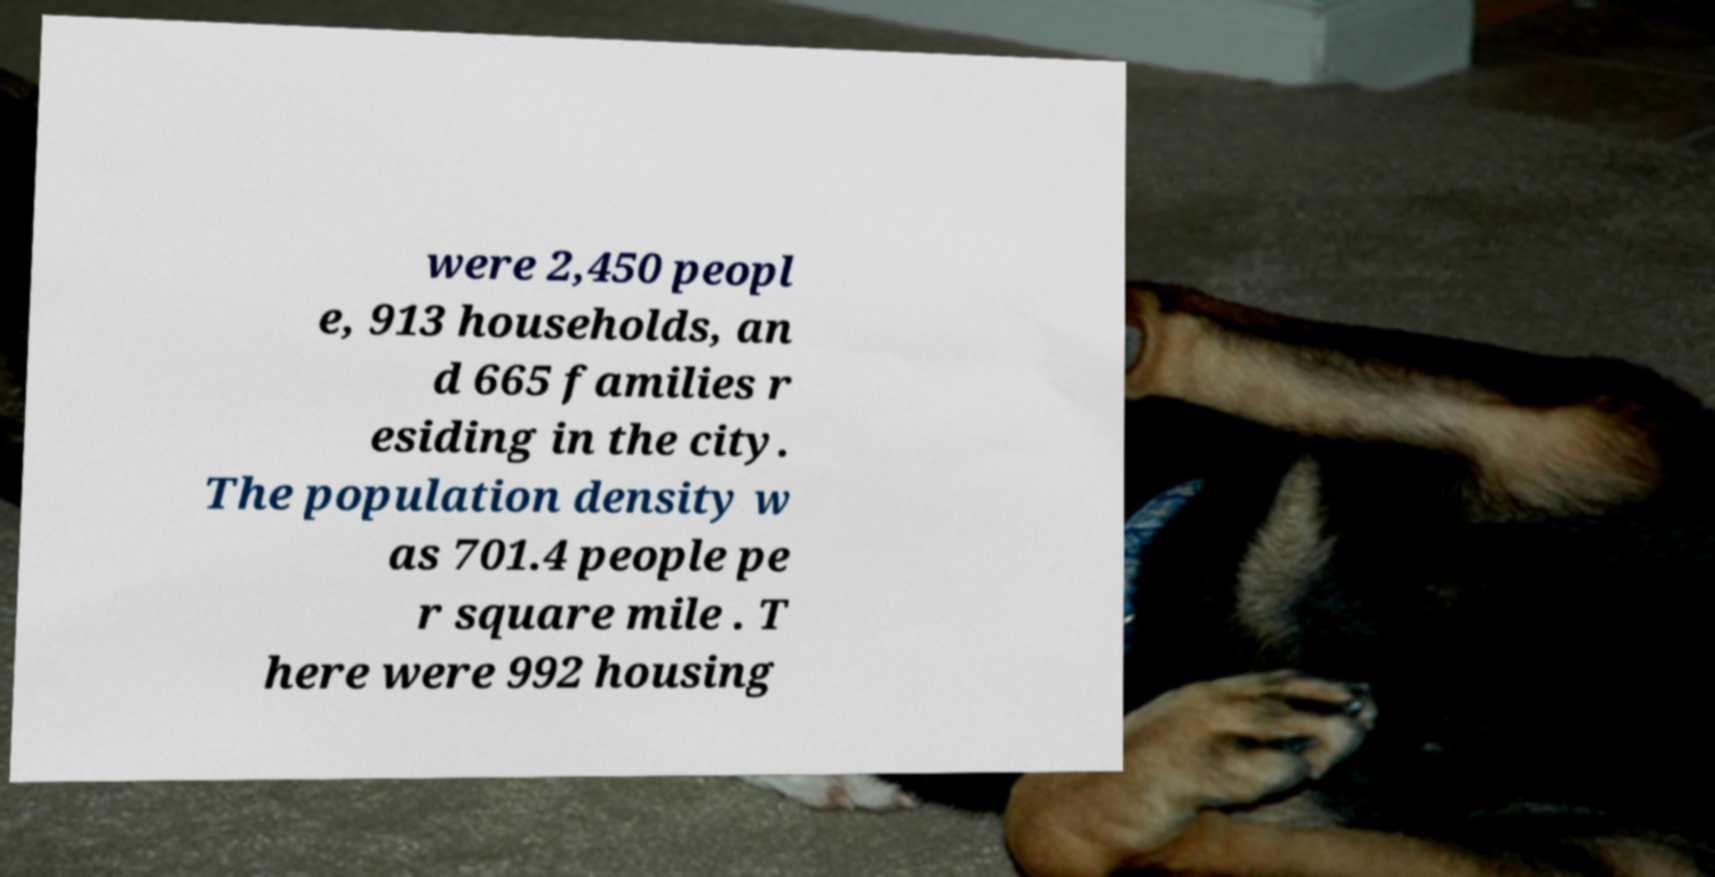Could you assist in decoding the text presented in this image and type it out clearly? were 2,450 peopl e, 913 households, an d 665 families r esiding in the city. The population density w as 701.4 people pe r square mile . T here were 992 housing 